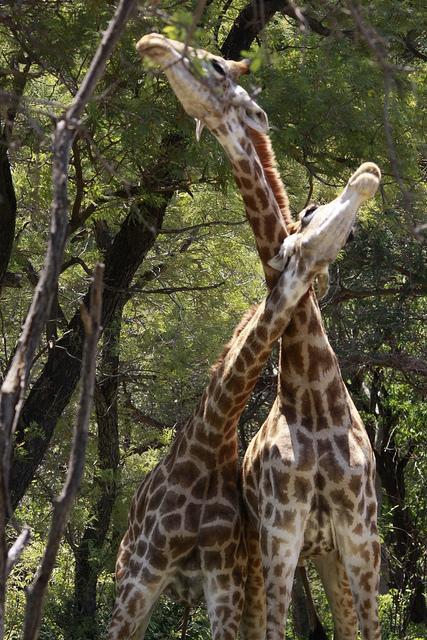How many giraffes are there?
Give a very brief answer. 2. How many kites do you see?
Give a very brief answer. 0. 